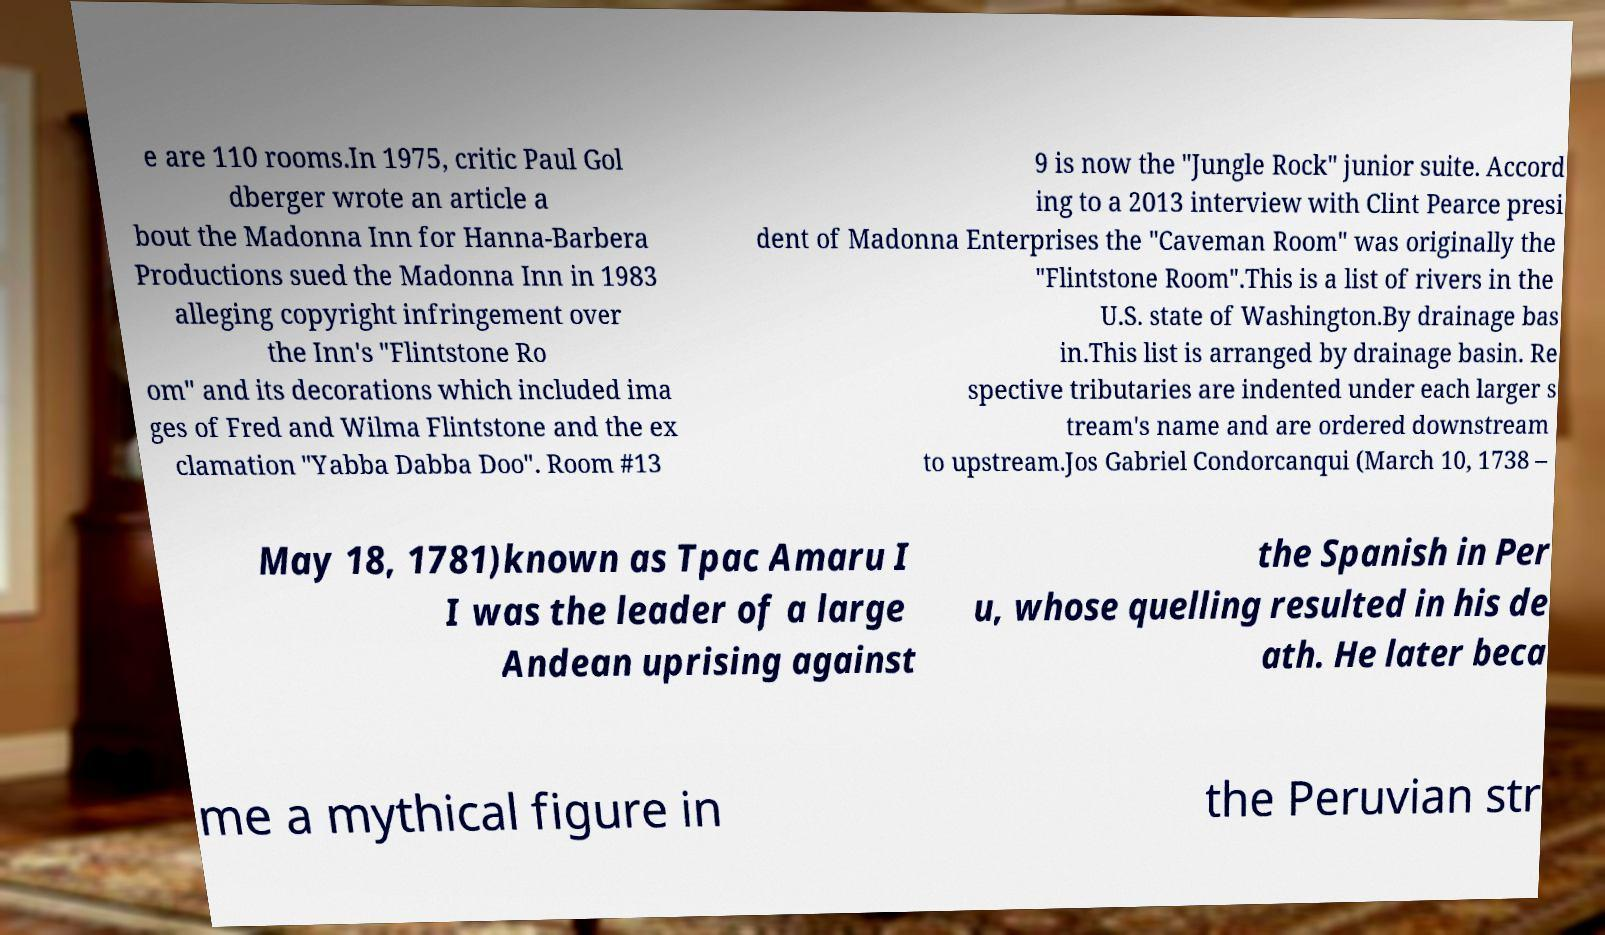Please read and relay the text visible in this image. What does it say? e are 110 rooms.In 1975, critic Paul Gol dberger wrote an article a bout the Madonna Inn for Hanna-Barbera Productions sued the Madonna Inn in 1983 alleging copyright infringement over the Inn's "Flintstone Ro om" and its decorations which included ima ges of Fred and Wilma Flintstone and the ex clamation "Yabba Dabba Doo". Room #13 9 is now the "Jungle Rock" junior suite. Accord ing to a 2013 interview with Clint Pearce presi dent of Madonna Enterprises the "Caveman Room" was originally the "Flintstone Room".This is a list of rivers in the U.S. state of Washington.By drainage bas in.This list is arranged by drainage basin. Re spective tributaries are indented under each larger s tream's name and are ordered downstream to upstream.Jos Gabriel Condorcanqui (March 10, 1738 – May 18, 1781)known as Tpac Amaru I I was the leader of a large Andean uprising against the Spanish in Per u, whose quelling resulted in his de ath. He later beca me a mythical figure in the Peruvian str 